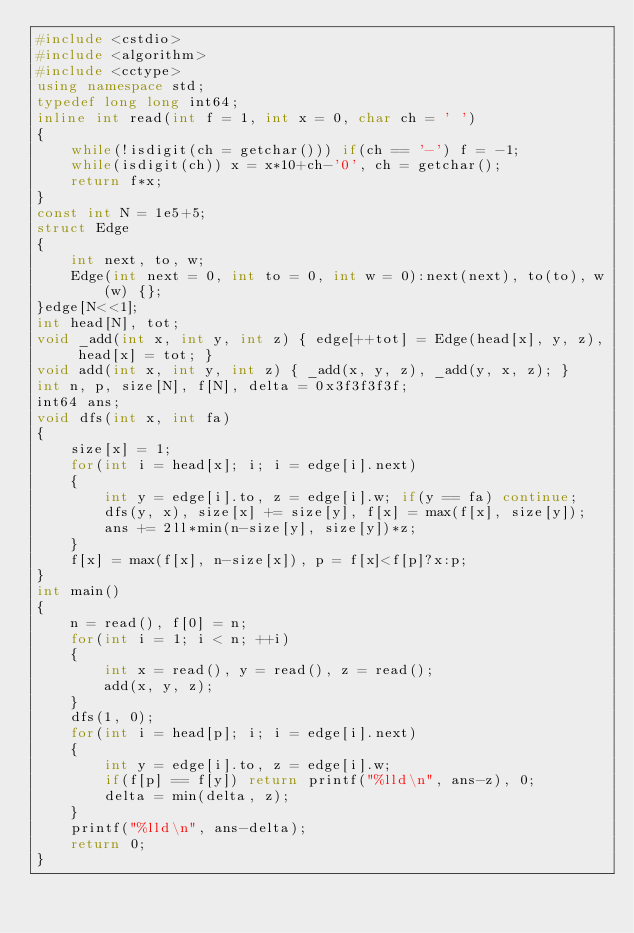<code> <loc_0><loc_0><loc_500><loc_500><_C++_>#include <cstdio>
#include <algorithm>
#include <cctype>
using namespace std;
typedef long long int64;
inline int read(int f = 1, int x = 0, char ch = ' ')
{
    while(!isdigit(ch = getchar())) if(ch == '-') f = -1;
    while(isdigit(ch)) x = x*10+ch-'0', ch = getchar();
    return f*x;
}
const int N = 1e5+5;
struct Edge
{
    int next, to, w;
    Edge(int next = 0, int to = 0, int w = 0):next(next), to(to), w(w) {};
}edge[N<<1];
int head[N], tot;
void _add(int x, int y, int z) { edge[++tot] = Edge(head[x], y, z), head[x] = tot; }
void add(int x, int y, int z) { _add(x, y, z), _add(y, x, z); }
int n, p, size[N], f[N], delta = 0x3f3f3f3f;
int64 ans;
void dfs(int x, int fa)
{
    size[x] = 1;
    for(int i = head[x]; i; i = edge[i].next)
    {
        int y = edge[i].to, z = edge[i].w; if(y == fa) continue;
        dfs(y, x), size[x] += size[y], f[x] = max(f[x], size[y]);
        ans += 2ll*min(n-size[y], size[y])*z;
    }
    f[x] = max(f[x], n-size[x]), p = f[x]<f[p]?x:p;
}
int main()
{
    n = read(), f[0] = n;
    for(int i = 1; i < n; ++i) 
    {
        int x = read(), y = read(), z = read();
        add(x, y, z);
    }
    dfs(1, 0);
    for(int i = head[p]; i; i = edge[i].next)
    {
        int y = edge[i].to, z = edge[i].w;
        if(f[p] == f[y]) return printf("%lld\n", ans-z), 0;
        delta = min(delta, z);
    }
    printf("%lld\n", ans-delta);
    return 0;
}</code> 